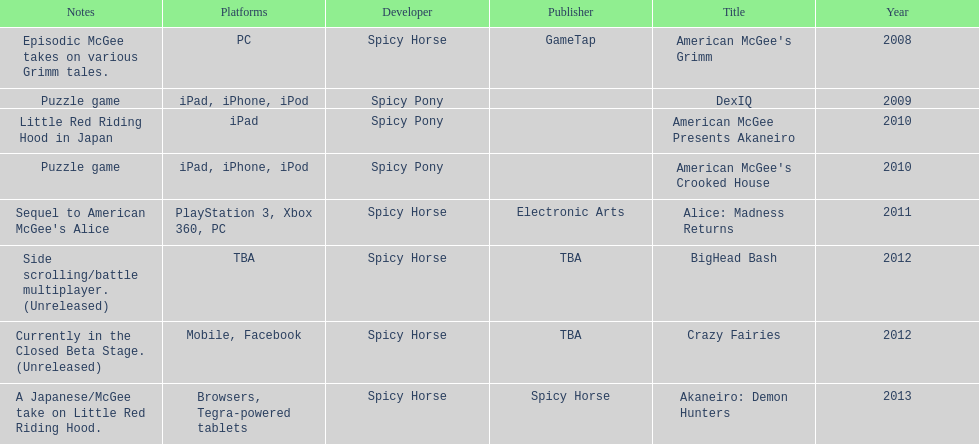What was the last game created by spicy horse Akaneiro: Demon Hunters. 